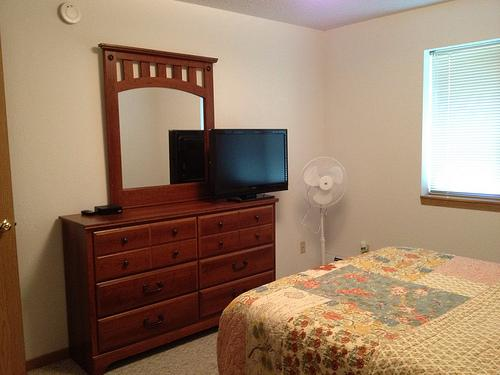Could you name the items that are part of the furniture in the room? The furniture items in the room include a made-up bed, a dresser against the wall, a chest drawer, and a mirror on the dresser. Determine the main colors in the image based on the object descriptions. The primary colors in the image are white (fan), brown (dresser), and black (TV). What type of electrical devices can you find in the image? A white standing fan, a smoke detector, and a TV on the dresser are the electrical devices in the image. Analyze the given image and describe feelings or emotions that the scene might evoke. The scene conveys a sense of calm and orderliness with its arranged furniture and tidiness. In this image, identify the objects related to safety. A smoke detector and a smoke alarm are related to safety in the image. Give a brief overview of the scene captured in the image. The image depicts a furnished room with a bed, dresser, chest drawers, and electrical devices such as a fan, TV, and smoke detector. Please count the number of chest drawers described in the image. There are 9 distinct chest drawer descriptions in the image. What are some items found on the wall of the room in the image? On the wall, there are horizontal blinds on the window and a smoke detector. Create a caption about the main object in the bottom-left corner of the image. A beautiful chest drawer sits adorned with handles in the room's cozy corner. What are the objects that can be controlled using one's hands in the image? The objects that can be controlled using one's hands are the knob on the door, the handle on the dresser, and the chest drawer. Which object is present at coordinates X:427 Y:39 Width:71 Height:71? A) the horizontal blinds on the window B) the TV on the dresser C) the smoke detector on the wall A) the horizontal blinds on the window Find an alternative way to describe the object at X:1 Y:220 Width:10 Height:10. a small round door knob What can one infer about the furniture arrangement in this room? There is a focus on storage with the presence of the dresser and numerous chest drawers. Describe the object found at the bottom left corner of the image. the edge of the wooden door Detail the specific locations and types of any safety devices found in the room. a smoke detector on the wall (X:59 Y:1 Width:22 Height:22) and a smoke alarm in a room (X:56 Y:1 Width:27 Height:27) Which events are happening in this room based on the captions? No events detected, only objects described. Is any object blocking the view of the dresser's mirror at X:98 Y:41 Width:120 Height:120? No object is blocking the view of the mirror on the dresser. Describe the object at X:217 Y:248 Width:281 Height:281 in a poetic way. A well-made bed sits regally, a comforting sanctuary in the room's embrace Recreate a description of the object located at X:1 Y:220 Width:10 Height:10 in other words. the little round doorknob inviting entry How many drawers are in the room based on the provided captions? 9 What is the main theme of the room? The main theme of the room focuses on storage and furniture layout. Determine if there is safety equipment present in the room by identifying an object at X:59 Y:1 Width:22 Height:22. the smoke detector on the wall Which object in the image is described by the coordinates X:299 Y:156 Width:47 Height:47? the white standing fan List the objects found at X:298 Y:155 Width:50 Height:50 and X:59 Y:1 Width:22 Height:22.  the standing fan is white, a smoke alarm in a room Please provide a creative description of an object at X:142 Y:280 Width:20 Height:20. a tiny metallic handle catching the light on the dresser What emotion is being expressed by the person in this scene? There is no person in the scene. What is the dominant furniture piece in the room? the dresser against the wall Can you identify and describe the object seen at X:209 Y:127 Width:79 Height:79 in a different phrasing? a television resting on the dresser 